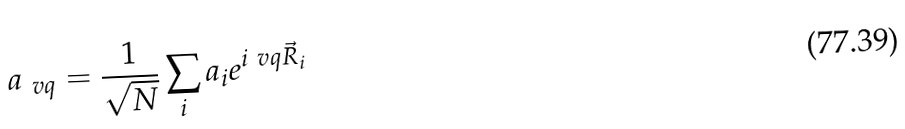Convert formula to latex. <formula><loc_0><loc_0><loc_500><loc_500>a _ { \ v q } = \frac { 1 } { \sqrt { N } } \sum _ { i } a _ { i } e ^ { i \ v q \vec { R } _ { i } }</formula> 